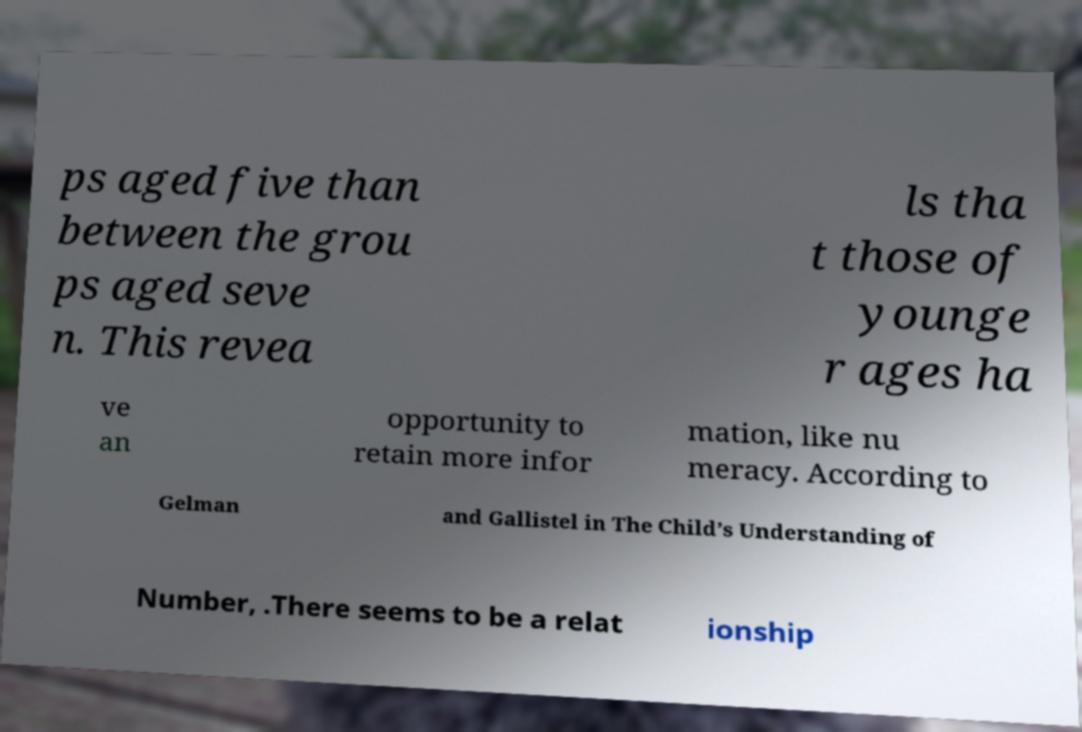Can you read and provide the text displayed in the image?This photo seems to have some interesting text. Can you extract and type it out for me? ps aged five than between the grou ps aged seve n. This revea ls tha t those of younge r ages ha ve an opportunity to retain more infor mation, like nu meracy. According to Gelman and Gallistel in The Child’s Understanding of Number, .There seems to be a relat ionship 